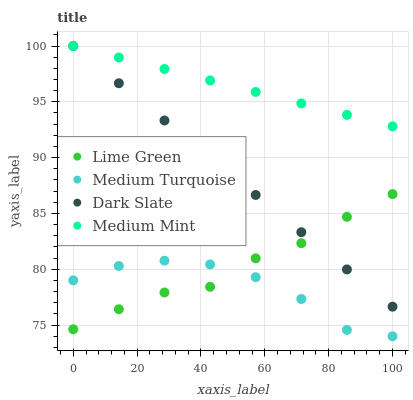Does Medium Turquoise have the minimum area under the curve?
Answer yes or no. Yes. Does Medium Mint have the maximum area under the curve?
Answer yes or no. Yes. Does Dark Slate have the minimum area under the curve?
Answer yes or no. No. Does Dark Slate have the maximum area under the curve?
Answer yes or no. No. Is Dark Slate the smoothest?
Answer yes or no. Yes. Is Medium Turquoise the roughest?
Answer yes or no. Yes. Is Lime Green the smoothest?
Answer yes or no. No. Is Lime Green the roughest?
Answer yes or no. No. Does Medium Turquoise have the lowest value?
Answer yes or no. Yes. Does Dark Slate have the lowest value?
Answer yes or no. No. Does Dark Slate have the highest value?
Answer yes or no. Yes. Does Lime Green have the highest value?
Answer yes or no. No. Is Medium Turquoise less than Dark Slate?
Answer yes or no. Yes. Is Medium Mint greater than Lime Green?
Answer yes or no. Yes. Does Lime Green intersect Dark Slate?
Answer yes or no. Yes. Is Lime Green less than Dark Slate?
Answer yes or no. No. Is Lime Green greater than Dark Slate?
Answer yes or no. No. Does Medium Turquoise intersect Dark Slate?
Answer yes or no. No. 